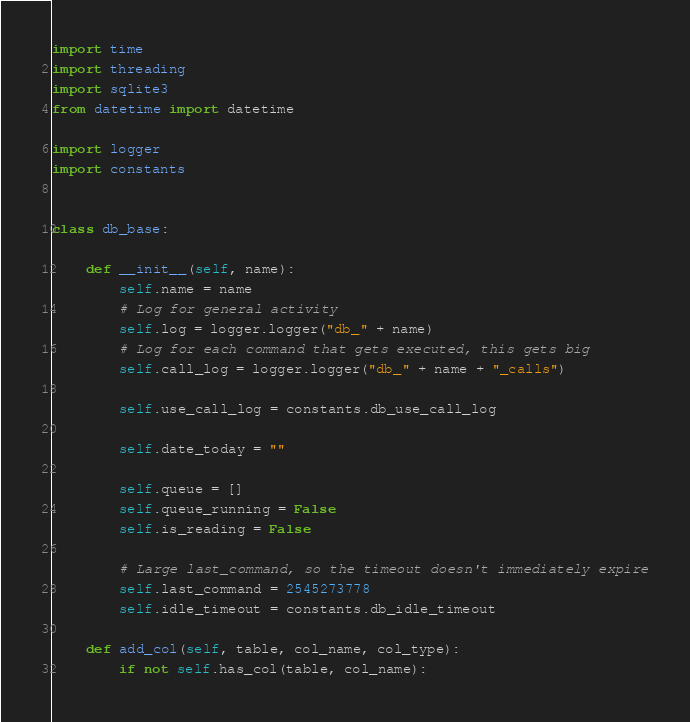<code> <loc_0><loc_0><loc_500><loc_500><_Python_>import time
import threading
import sqlite3
from datetime import datetime

import logger
import constants


class db_base:

    def __init__(self, name):
        self.name = name
        # Log for general activity
        self.log = logger.logger("db_" + name)
        # Log for each command that gets executed, this gets big
        self.call_log = logger.logger("db_" + name + "_calls")

        self.use_call_log = constants.db_use_call_log

        self.date_today = ""

        self.queue = []
        self.queue_running = False
        self.is_reading = False

        # Large last_command, so the timeout doesn't immediately expire
        self.last_command = 2545273778
        self.idle_timeout = constants.db_idle_timeout

    def add_col(self, table, col_name, col_type):
        if not self.has_col(table, col_name):</code> 